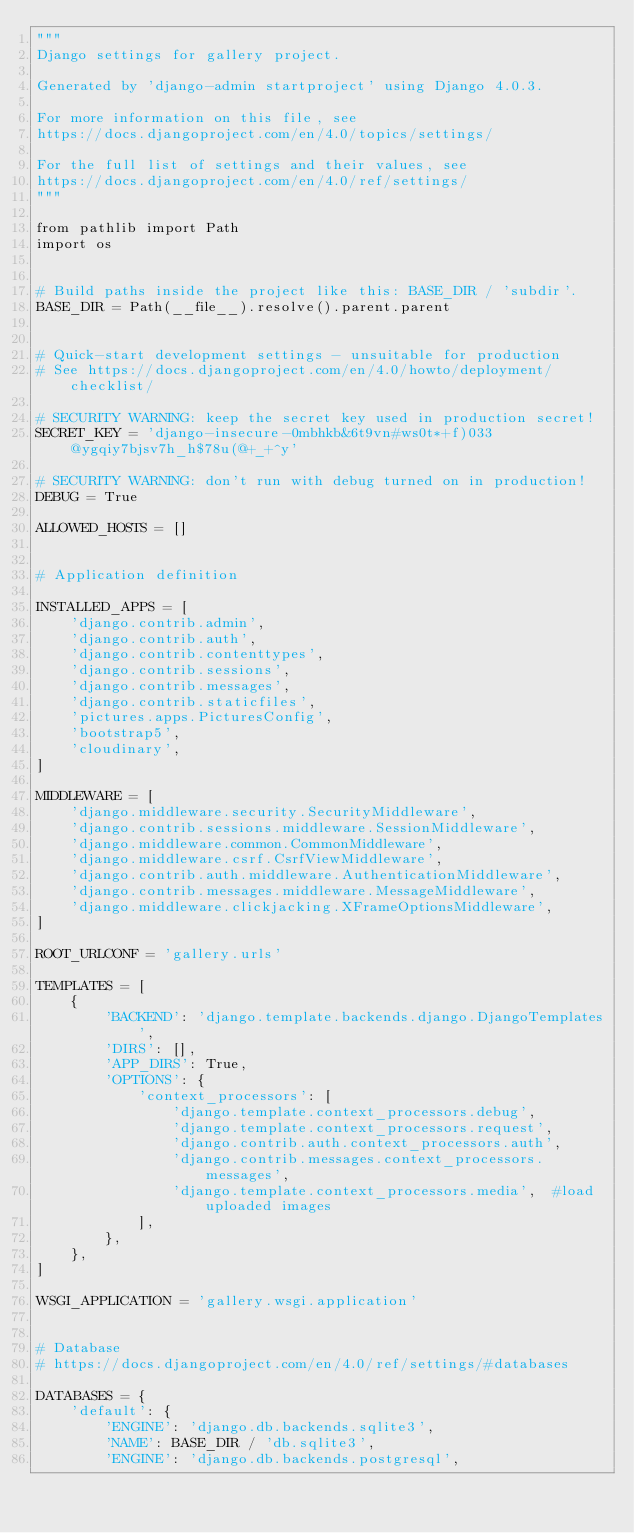<code> <loc_0><loc_0><loc_500><loc_500><_Python_>"""
Django settings for gallery project.

Generated by 'django-admin startproject' using Django 4.0.3.

For more information on this file, see
https://docs.djangoproject.com/en/4.0/topics/settings/

For the full list of settings and their values, see
https://docs.djangoproject.com/en/4.0/ref/settings/
"""

from pathlib import Path
import os


# Build paths inside the project like this: BASE_DIR / 'subdir'.
BASE_DIR = Path(__file__).resolve().parent.parent


# Quick-start development settings - unsuitable for production
# See https://docs.djangoproject.com/en/4.0/howto/deployment/checklist/

# SECURITY WARNING: keep the secret key used in production secret!
SECRET_KEY = 'django-insecure-0mbhkb&6t9vn#ws0t*+f)033@ygqiy7bjsv7h_h$78u(@+_+^y'

# SECURITY WARNING: don't run with debug turned on in production!
DEBUG = True

ALLOWED_HOSTS = []


# Application definition

INSTALLED_APPS = [
    'django.contrib.admin',
    'django.contrib.auth',
    'django.contrib.contenttypes',
    'django.contrib.sessions',
    'django.contrib.messages',
    'django.contrib.staticfiles',
    'pictures.apps.PicturesConfig',
    'bootstrap5',
    'cloudinary',
]

MIDDLEWARE = [
    'django.middleware.security.SecurityMiddleware',
    'django.contrib.sessions.middleware.SessionMiddleware',
    'django.middleware.common.CommonMiddleware',
    'django.middleware.csrf.CsrfViewMiddleware',
    'django.contrib.auth.middleware.AuthenticationMiddleware',
    'django.contrib.messages.middleware.MessageMiddleware',
    'django.middleware.clickjacking.XFrameOptionsMiddleware',
]

ROOT_URLCONF = 'gallery.urls'

TEMPLATES = [
    {
        'BACKEND': 'django.template.backends.django.DjangoTemplates',
        'DIRS': [],
        'APP_DIRS': True,
        'OPTIONS': {
            'context_processors': [
                'django.template.context_processors.debug',
                'django.template.context_processors.request',
                'django.contrib.auth.context_processors.auth',
                'django.contrib.messages.context_processors.messages',
                'django.template.context_processors.media',  #load uploaded images
            ],
        },
    },
]

WSGI_APPLICATION = 'gallery.wsgi.application'


# Database
# https://docs.djangoproject.com/en/4.0/ref/settings/#databases

DATABASES = {
    'default': {
        'ENGINE': 'django.db.backends.sqlite3',
        'NAME': BASE_DIR / 'db.sqlite3',
        'ENGINE': 'django.db.backends.postgresql',</code> 